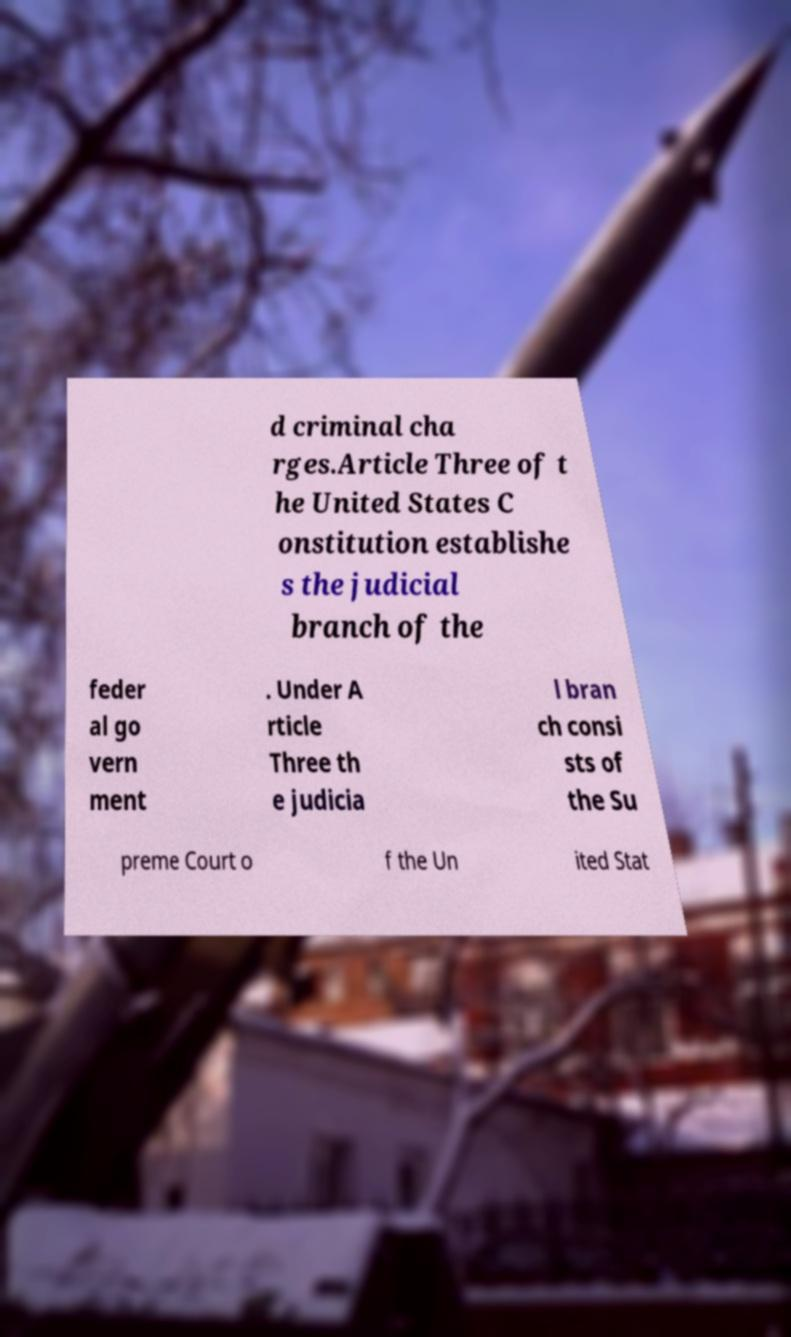Please read and relay the text visible in this image. What does it say? d criminal cha rges.Article Three of t he United States C onstitution establishe s the judicial branch of the feder al go vern ment . Under A rticle Three th e judicia l bran ch consi sts of the Su preme Court o f the Un ited Stat 